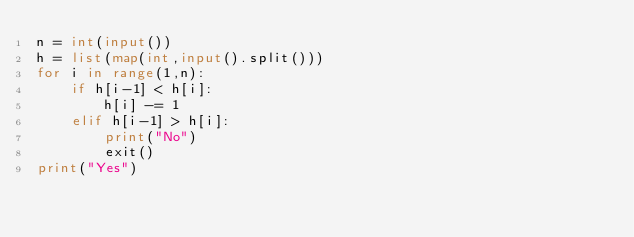<code> <loc_0><loc_0><loc_500><loc_500><_Python_>n = int(input())
h = list(map(int,input().split()))
for i in range(1,n):
    if h[i-1] < h[i]:
        h[i] -= 1
    elif h[i-1] > h[i]:
        print("No")
        exit()
print("Yes")
</code> 